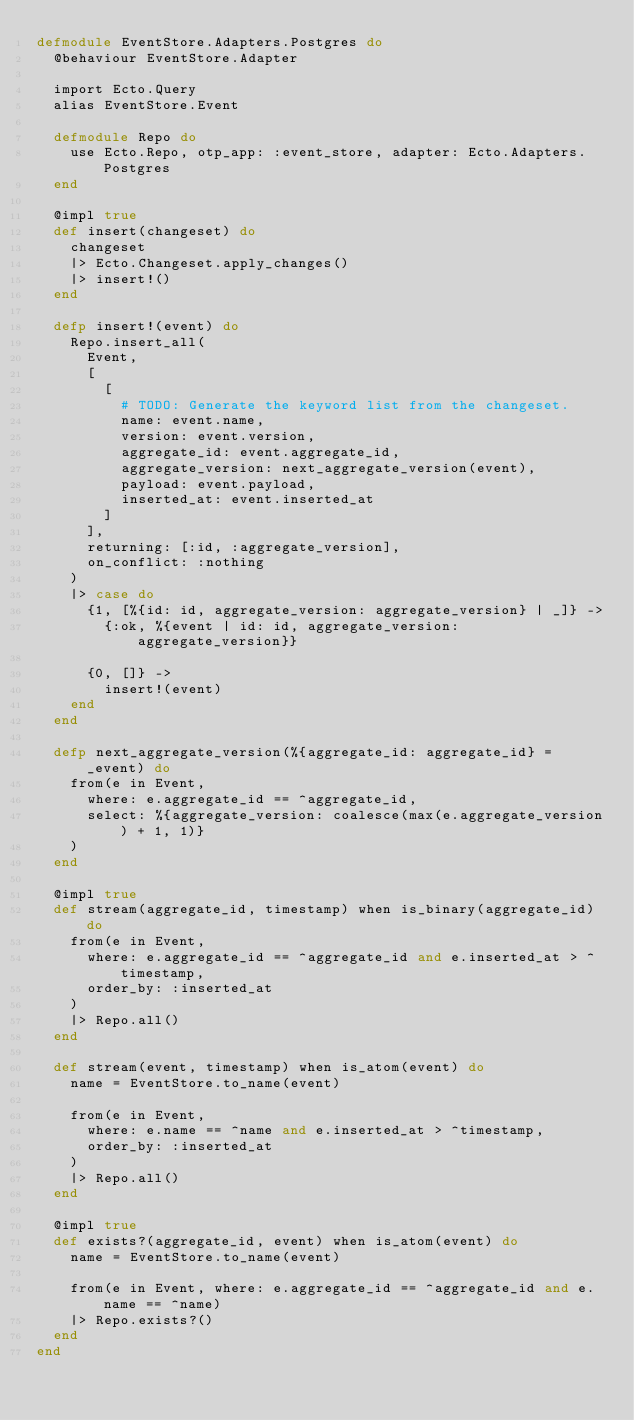<code> <loc_0><loc_0><loc_500><loc_500><_Elixir_>defmodule EventStore.Adapters.Postgres do
  @behaviour EventStore.Adapter

  import Ecto.Query
  alias EventStore.Event

  defmodule Repo do
    use Ecto.Repo, otp_app: :event_store, adapter: Ecto.Adapters.Postgres
  end

  @impl true
  def insert(changeset) do
    changeset
    |> Ecto.Changeset.apply_changes()
    |> insert!()
  end

  defp insert!(event) do
    Repo.insert_all(
      Event,
      [
        [
          # TODO: Generate the keyword list from the changeset.
          name: event.name,
          version: event.version,
          aggregate_id: event.aggregate_id,
          aggregate_version: next_aggregate_version(event),
          payload: event.payload,
          inserted_at: event.inserted_at
        ]
      ],
      returning: [:id, :aggregate_version],
      on_conflict: :nothing
    )
    |> case do
      {1, [%{id: id, aggregate_version: aggregate_version} | _]} ->
        {:ok, %{event | id: id, aggregate_version: aggregate_version}}

      {0, []} ->
        insert!(event)
    end
  end

  defp next_aggregate_version(%{aggregate_id: aggregate_id} = _event) do
    from(e in Event,
      where: e.aggregate_id == ^aggregate_id,
      select: %{aggregate_version: coalesce(max(e.aggregate_version) + 1, 1)}
    )
  end

  @impl true
  def stream(aggregate_id, timestamp) when is_binary(aggregate_id) do
    from(e in Event,
      where: e.aggregate_id == ^aggregate_id and e.inserted_at > ^timestamp,
      order_by: :inserted_at
    )
    |> Repo.all()
  end

  def stream(event, timestamp) when is_atom(event) do
    name = EventStore.to_name(event)

    from(e in Event,
      where: e.name == ^name and e.inserted_at > ^timestamp,
      order_by: :inserted_at
    )
    |> Repo.all()
  end

  @impl true
  def exists?(aggregate_id, event) when is_atom(event) do
    name = EventStore.to_name(event)

    from(e in Event, where: e.aggregate_id == ^aggregate_id and e.name == ^name)
    |> Repo.exists?()
  end
end
</code> 